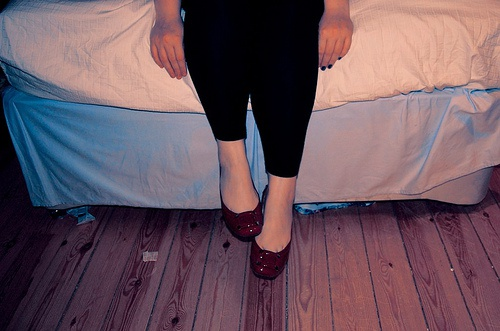Describe the objects in this image and their specific colors. I can see bed in black, gray, and lightpink tones and people in black, brown, salmon, and gray tones in this image. 